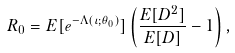<formula> <loc_0><loc_0><loc_500><loc_500>R _ { 0 } = E [ e ^ { - \Lambda ( \iota ; \theta _ { 0 } ) } ] \left ( \frac { E [ D ^ { 2 } ] } { E [ D ] } - 1 \right ) ,</formula> 